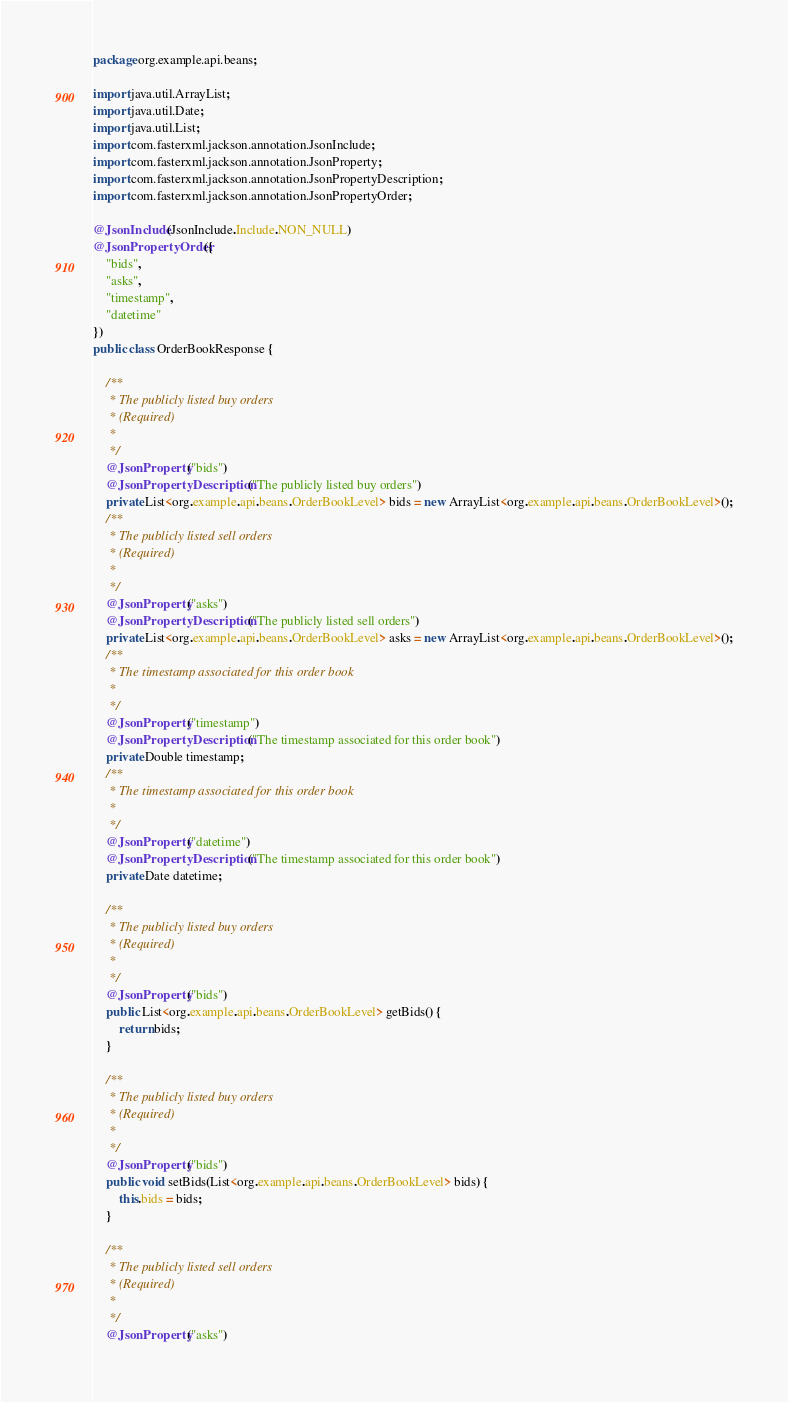Convert code to text. <code><loc_0><loc_0><loc_500><loc_500><_Java_>
package org.example.api.beans;

import java.util.ArrayList;
import java.util.Date;
import java.util.List;
import com.fasterxml.jackson.annotation.JsonInclude;
import com.fasterxml.jackson.annotation.JsonProperty;
import com.fasterxml.jackson.annotation.JsonPropertyDescription;
import com.fasterxml.jackson.annotation.JsonPropertyOrder;

@JsonInclude(JsonInclude.Include.NON_NULL)
@JsonPropertyOrder({
    "bids",
    "asks",
    "timestamp",
    "datetime"
})
public class OrderBookResponse {

    /**
     * The publicly listed buy orders
     * (Required)
     * 
     */
    @JsonProperty("bids")
    @JsonPropertyDescription("The publicly listed buy orders")
    private List<org.example.api.beans.OrderBookLevel> bids = new ArrayList<org.example.api.beans.OrderBookLevel>();
    /**
     * The publicly listed sell orders
     * (Required)
     * 
     */
    @JsonProperty("asks")
    @JsonPropertyDescription("The publicly listed sell orders")
    private List<org.example.api.beans.OrderBookLevel> asks = new ArrayList<org.example.api.beans.OrderBookLevel>();
    /**
     * The timestamp associated for this order book
     * 
     */
    @JsonProperty("timestamp")
    @JsonPropertyDescription("The timestamp associated for this order book")
    private Double timestamp;
    /**
     * The timestamp associated for this order book
     * 
     */
    @JsonProperty("datetime")
    @JsonPropertyDescription("The timestamp associated for this order book")
    private Date datetime;

    /**
     * The publicly listed buy orders
     * (Required)
     * 
     */
    @JsonProperty("bids")
    public List<org.example.api.beans.OrderBookLevel> getBids() {
        return bids;
    }

    /**
     * The publicly listed buy orders
     * (Required)
     * 
     */
    @JsonProperty("bids")
    public void setBids(List<org.example.api.beans.OrderBookLevel> bids) {
        this.bids = bids;
    }

    /**
     * The publicly listed sell orders
     * (Required)
     * 
     */
    @JsonProperty("asks")</code> 